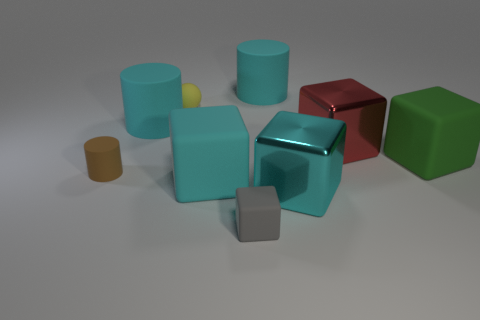What is the color of the metal cube behind the big green rubber thing?
Your answer should be very brief. Red. There is a big cyan rubber thing that is in front of the big cyan cylinder that is on the left side of the small cube; what shape is it?
Provide a succinct answer. Cube. Is the material of the big green object the same as the big cyan cylinder left of the small yellow matte object?
Give a very brief answer. Yes. What number of green objects have the same size as the red block?
Make the answer very short. 1. Are there fewer shiny blocks that are behind the tiny sphere than red objects?
Your response must be concise. Yes. There is a tiny yellow thing; how many big matte cubes are left of it?
Your answer should be compact. 0. There is a cyan rubber thing in front of the cyan cylinder that is in front of the cyan rubber cylinder that is on the right side of the small gray cube; how big is it?
Make the answer very short. Large. There is a small yellow object; does it have the same shape as the small brown rubber thing that is behind the gray matte thing?
Keep it short and to the point. No. What is the size of the cyan cube that is made of the same material as the tiny yellow object?
Your response must be concise. Large. Is there anything else that is the same color as the tiny sphere?
Provide a succinct answer. No. 